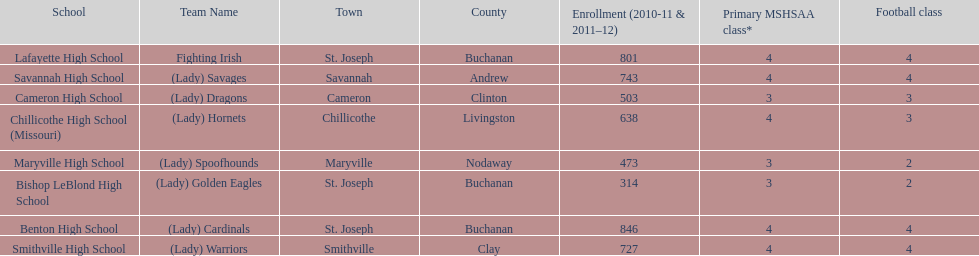Does lafayette high school or benton high school have green and grey as their colors? Lafayette High School. 